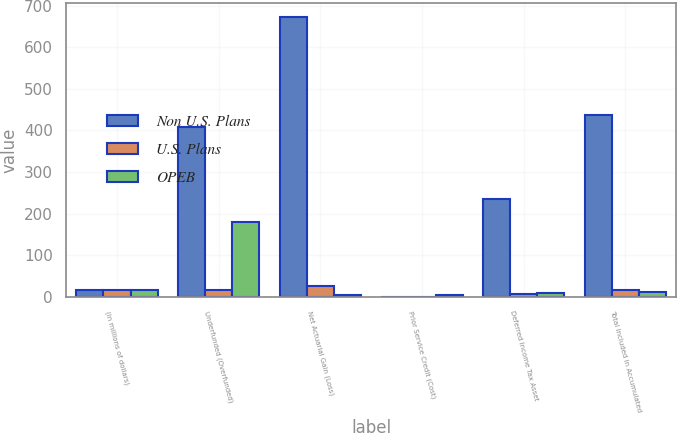<chart> <loc_0><loc_0><loc_500><loc_500><stacked_bar_chart><ecel><fcel>(in millions of dollars)<fcel>Underfunded (Overfunded)<fcel>Net Actuarial Gain (Loss)<fcel>Prior Service Credit (Cost)<fcel>Deferred Income Tax Asset<fcel>Total Included in Accumulated<nl><fcel>Non U.S. Plans<fcel>17.2<fcel>409<fcel>673.1<fcel>0.2<fcel>235.7<fcel>437.6<nl><fcel>U.S. Plans<fcel>17.2<fcel>17.6<fcel>25<fcel>0.2<fcel>8<fcel>17.2<nl><fcel>OPEB<fcel>17.2<fcel>179.2<fcel>4.1<fcel>4.9<fcel>9.9<fcel>10.7<nl></chart> 